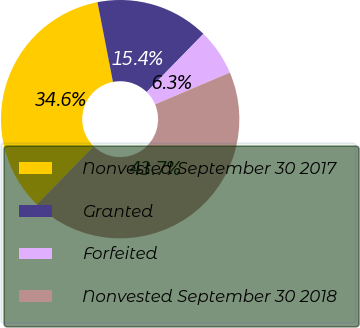<chart> <loc_0><loc_0><loc_500><loc_500><pie_chart><fcel>Nonvested September 30 2017<fcel>Granted<fcel>Forfeited<fcel>Nonvested September 30 2018<nl><fcel>34.64%<fcel>15.36%<fcel>6.3%<fcel>43.7%<nl></chart> 